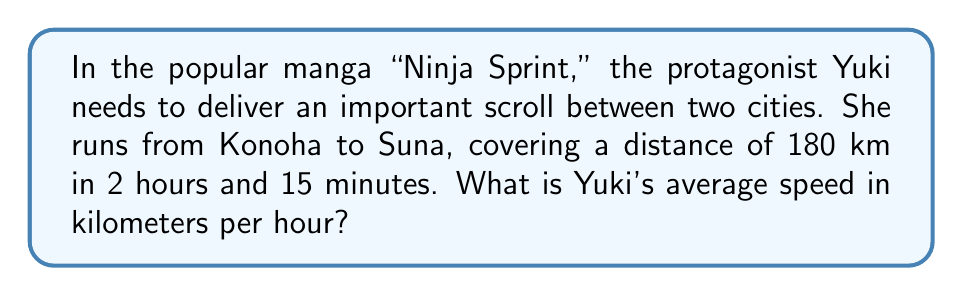Solve this math problem. Let's solve this step-by-step:

1) First, we need to convert the time into hours:
   2 hours and 15 minutes = 2.25 hours
   
   (Because 15 minutes is $\frac{1}{4}$ of an hour, or 0.25 hours)

2) Now we have the formula for average speed:
   $$ \text{Average Speed} = \frac{\text{Distance}}{\text{Time}} $$

3) Let's plug in our values:
   $$ \text{Average Speed} = \frac{180 \text{ km}}{2.25 \text{ hours}} $$

4) Now we can divide:
   $$ \text{Average Speed} = 80 \text{ km/h} $$

So, Yuki's average speed is 80 kilometers per hour.
Answer: 80 km/h 